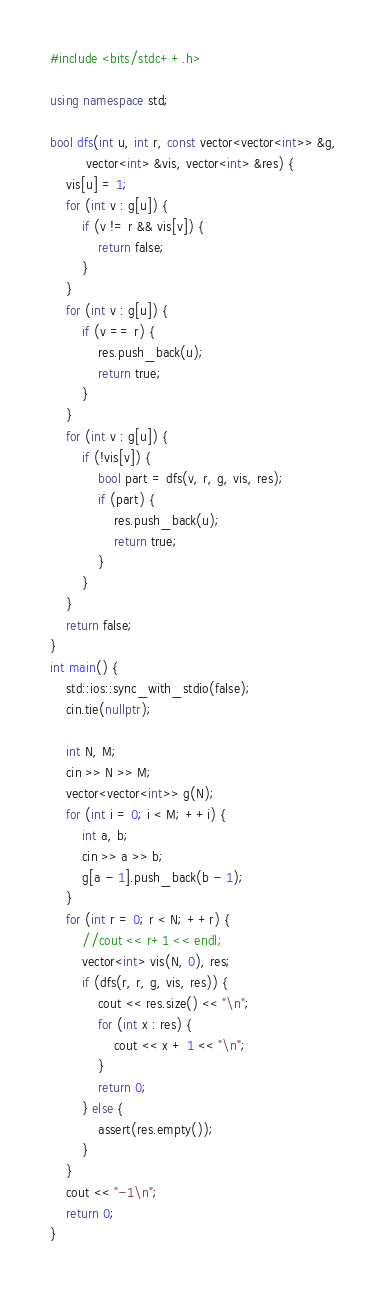<code> <loc_0><loc_0><loc_500><loc_500><_C++_>#include <bits/stdc++.h>

using namespace std;

bool dfs(int u, int r, const vector<vector<int>> &g,
         vector<int> &vis, vector<int> &res) {
    vis[u] = 1;
    for (int v : g[u]) {
        if (v != r && vis[v]) {
            return false;
        }
    }
    for (int v : g[u]) {
        if (v == r) {
            res.push_back(u);
            return true;
        }
    }
    for (int v : g[u]) {
        if (!vis[v]) {
            bool part = dfs(v, r, g, vis, res);
            if (part) {
                res.push_back(u);
                return true;
            }
        }
    }
    return false;
}
int main() {
    std::ios::sync_with_stdio(false); 
    cin.tie(nullptr);

    int N, M;
    cin >> N >> M;
    vector<vector<int>> g(N);
    for (int i = 0; i < M; ++i) {
        int a, b;
        cin >> a >> b;
        g[a - 1].push_back(b - 1);
    }
    for (int r = 0; r < N; ++r) {
        //cout << r+1 << endl;
        vector<int> vis(N, 0), res;
        if (dfs(r, r, g, vis, res)) {
            cout << res.size() << "\n";
            for (int x : res) {
                cout << x + 1 << "\n";
            }
            return 0;
        } else {
            assert(res.empty());
        }
    }
    cout << "-1\n";
    return 0;
}</code> 